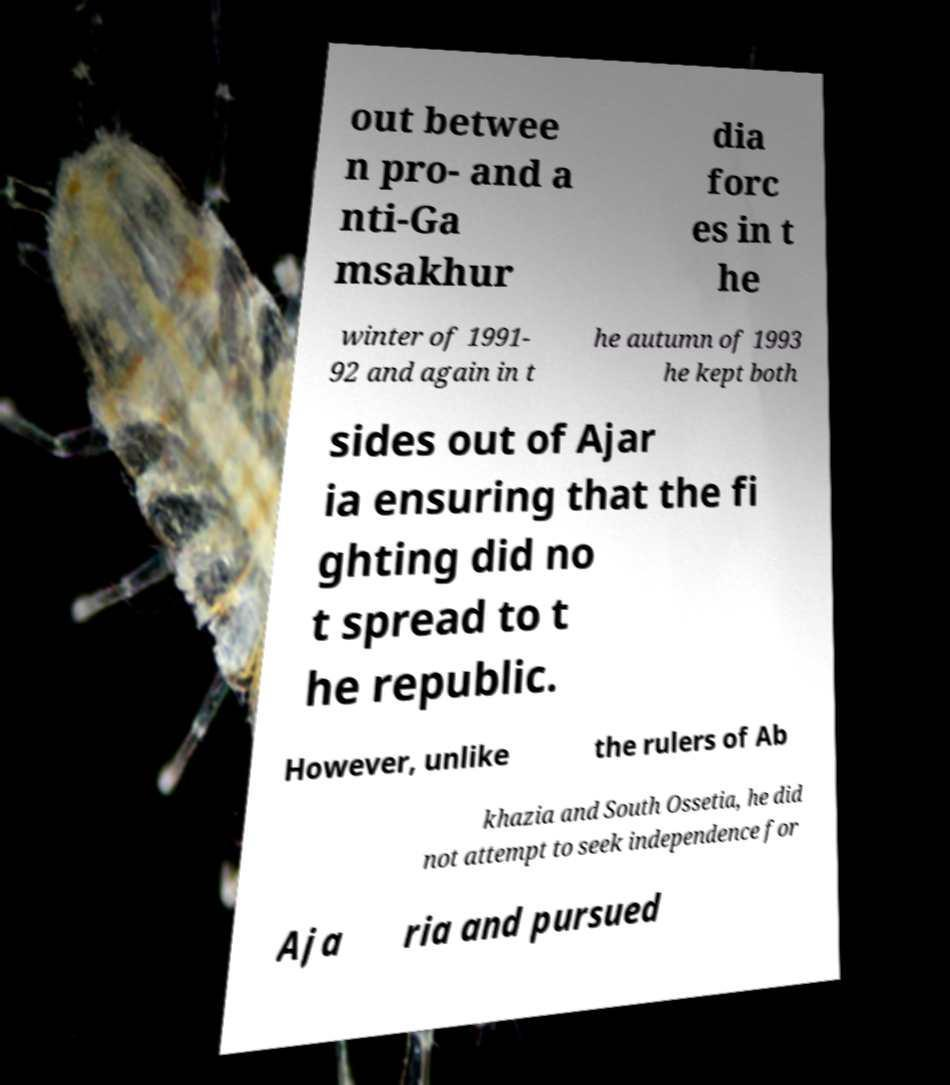For documentation purposes, I need the text within this image transcribed. Could you provide that? out betwee n pro- and a nti-Ga msakhur dia forc es in t he winter of 1991- 92 and again in t he autumn of 1993 he kept both sides out of Ajar ia ensuring that the fi ghting did no t spread to t he republic. However, unlike the rulers of Ab khazia and South Ossetia, he did not attempt to seek independence for Aja ria and pursued 